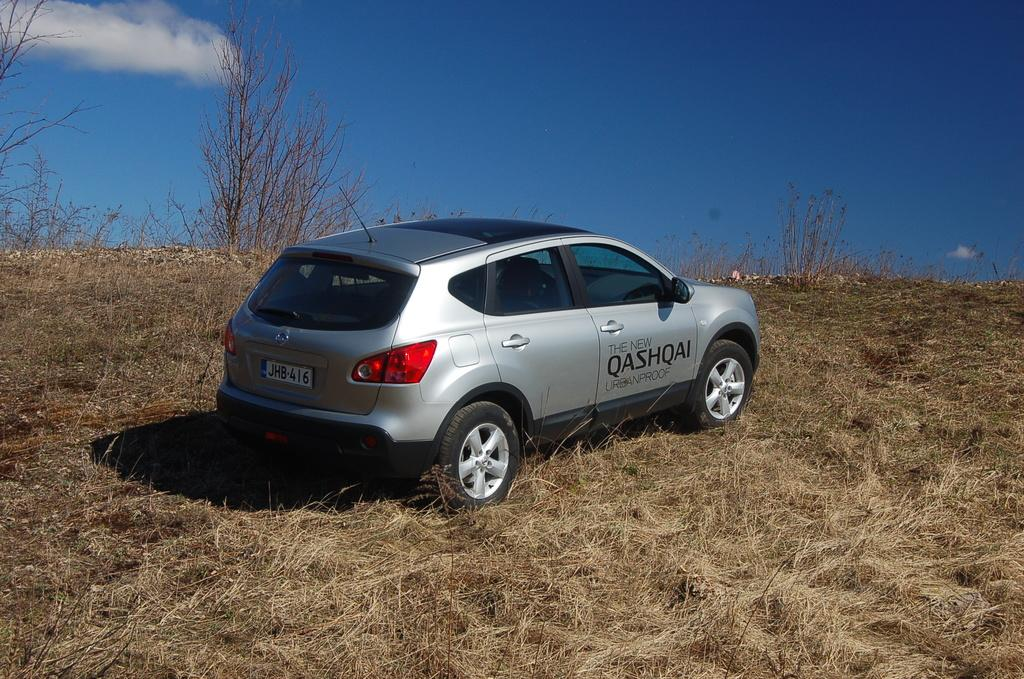What is the main subject of the image? The main subject of the image is a car on the grass. What type of plants can be seen in the image? There are bearer plants in the image. What can be seen in the sky in the background of the image? There are clouds visible in the sky in the background of the image. What type of house is depicted in the image? There is no house depicted in the image; it features a car on the grass and bearer plants. How does the car show respect to the bearer plants in the image? The car does not show respect to the bearer plants in the image; it is simply parked on the grass. 